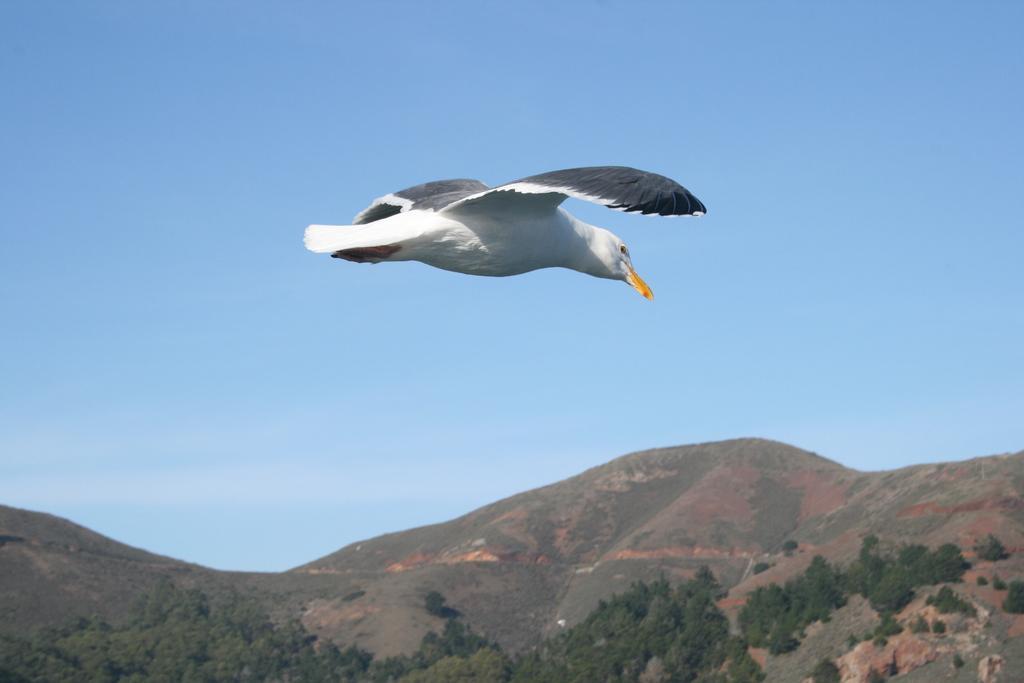Describe this image in one or two sentences. In the center of the picture there is a bird. At the bottom there are trees and hills. Sky is clear and it is sunny. 